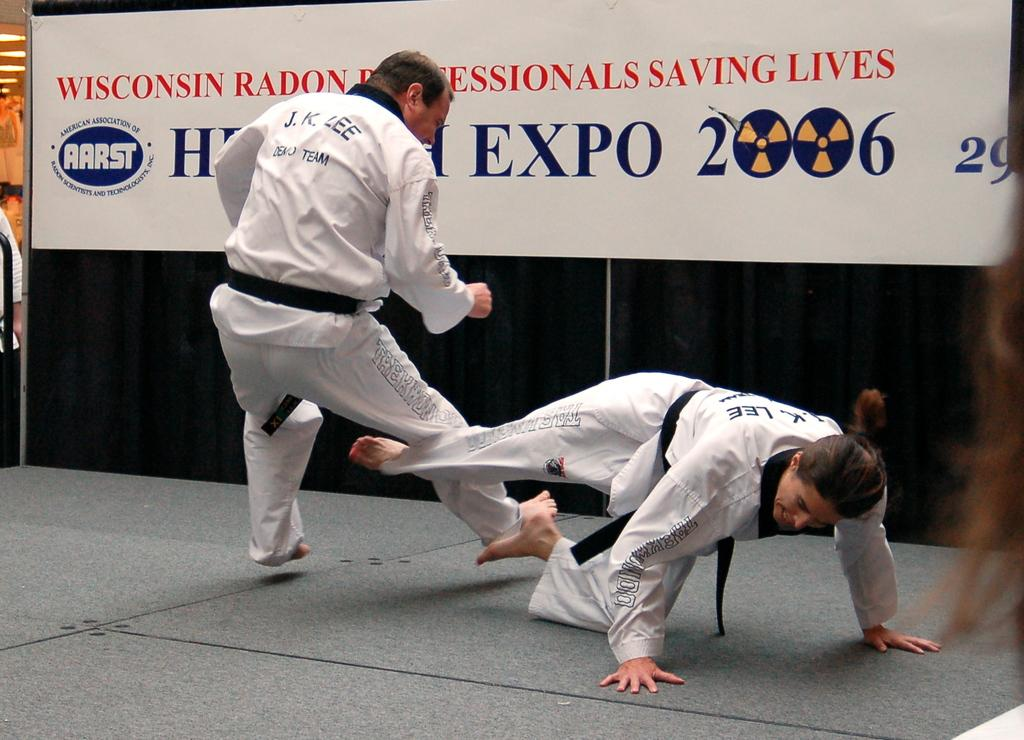How many people are in the image? There are two men in the image. What are the men wearing? The men are wearing white color shirts and track. What activity are the men engaged in? The men are playing karate. What can be seen in the background of the image? There is a white and blue color poster banner in the background. What type of bottle is placed on the bed in the image? There is no bottle or bed present in the image. 